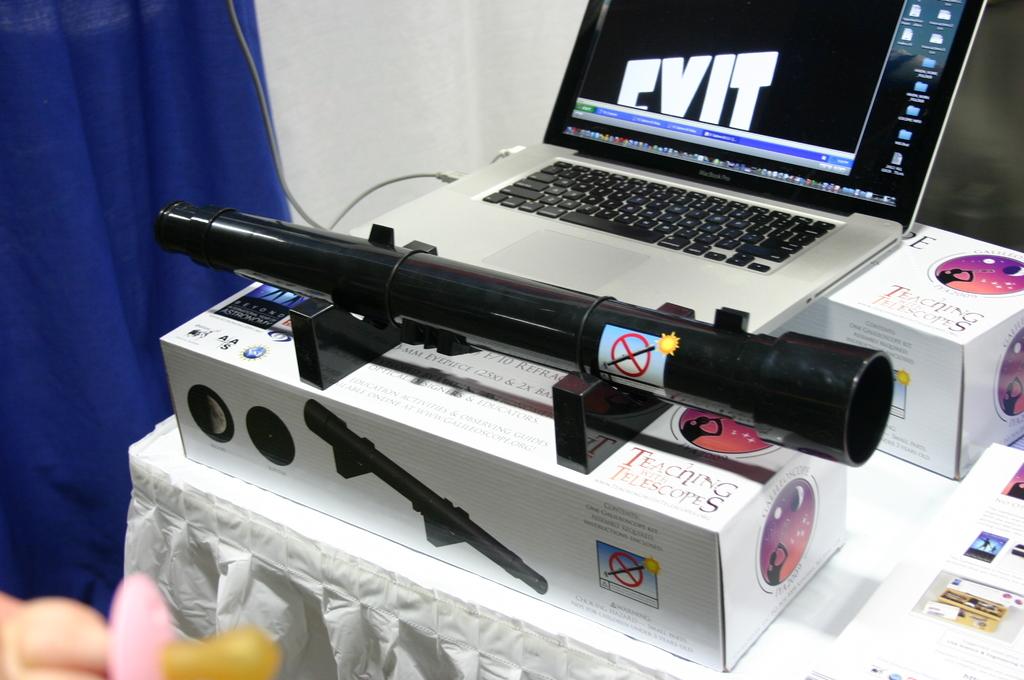What brand of scope is that?
Ensure brevity in your answer.  Unanswerable. What type of computer does this person use?
Your response must be concise. Unanswerable. 